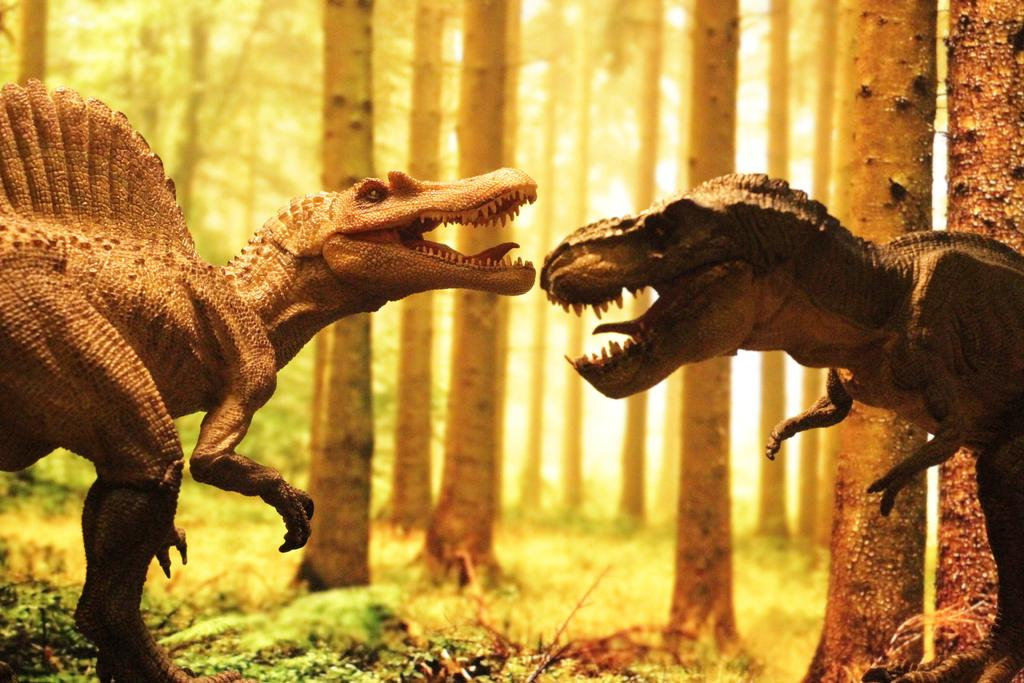What is located in the foreground of the picture? There are dinosaurs, plants, and trees in the foreground of the picture. Can you describe the plants in the foreground? The plants in the foreground are not specified, but they are present alongside the dinosaurs and trees. What is visible in both the foreground and background of the picture? Trees are visible in both the foreground and background of the picture. What type of linen is draped over the dinosaurs in the image? There is no linen present in the image, as the image features dinosaurs, plants, and trees. 